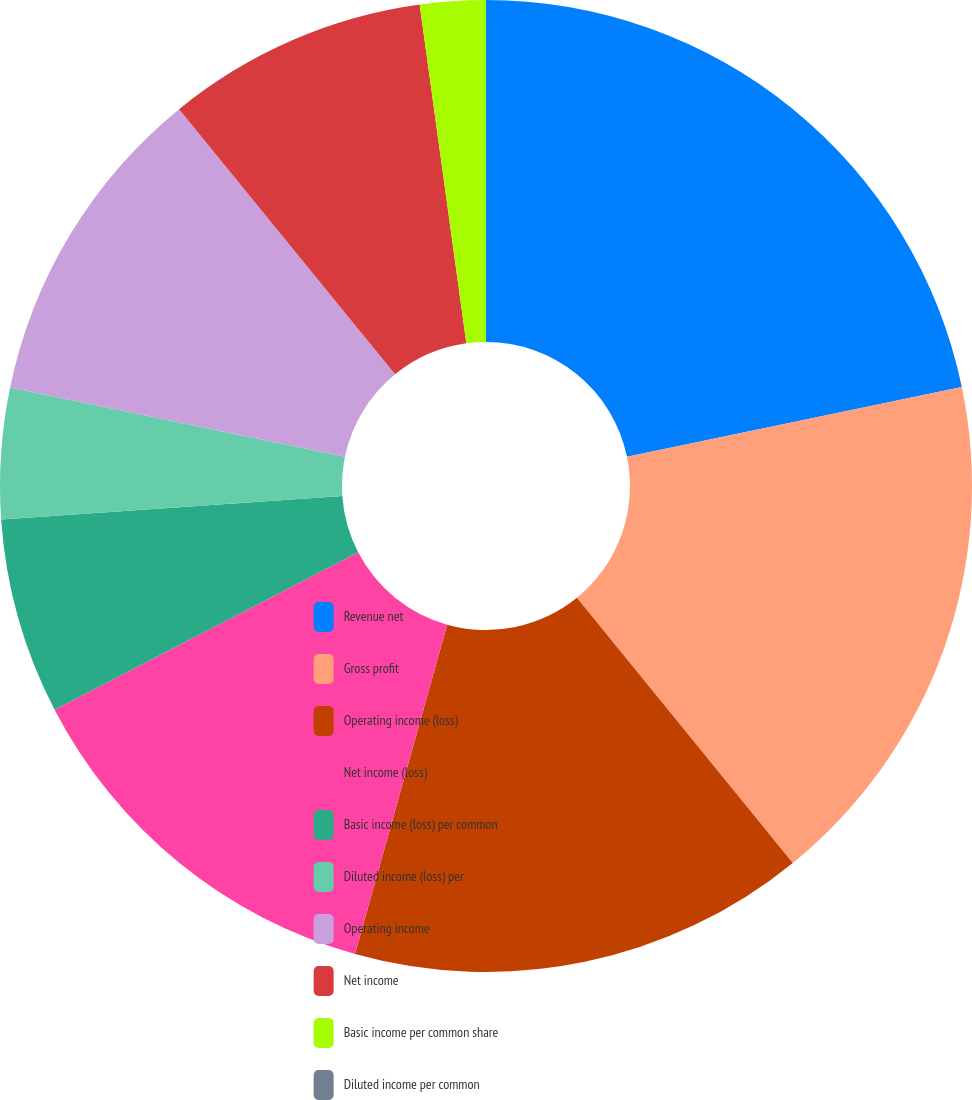<chart> <loc_0><loc_0><loc_500><loc_500><pie_chart><fcel>Revenue net<fcel>Gross profit<fcel>Operating income (loss)<fcel>Net income (loss)<fcel>Basic income (loss) per common<fcel>Diluted income (loss) per<fcel>Operating income<fcel>Net income<fcel>Basic income per common share<fcel>Diluted income per common<nl><fcel>21.74%<fcel>17.39%<fcel>15.22%<fcel>13.04%<fcel>6.52%<fcel>4.35%<fcel>10.87%<fcel>8.7%<fcel>2.18%<fcel>0.0%<nl></chart> 